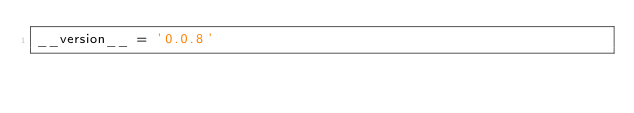Convert code to text. <code><loc_0><loc_0><loc_500><loc_500><_Python_>__version__ = '0.0.8'
</code> 